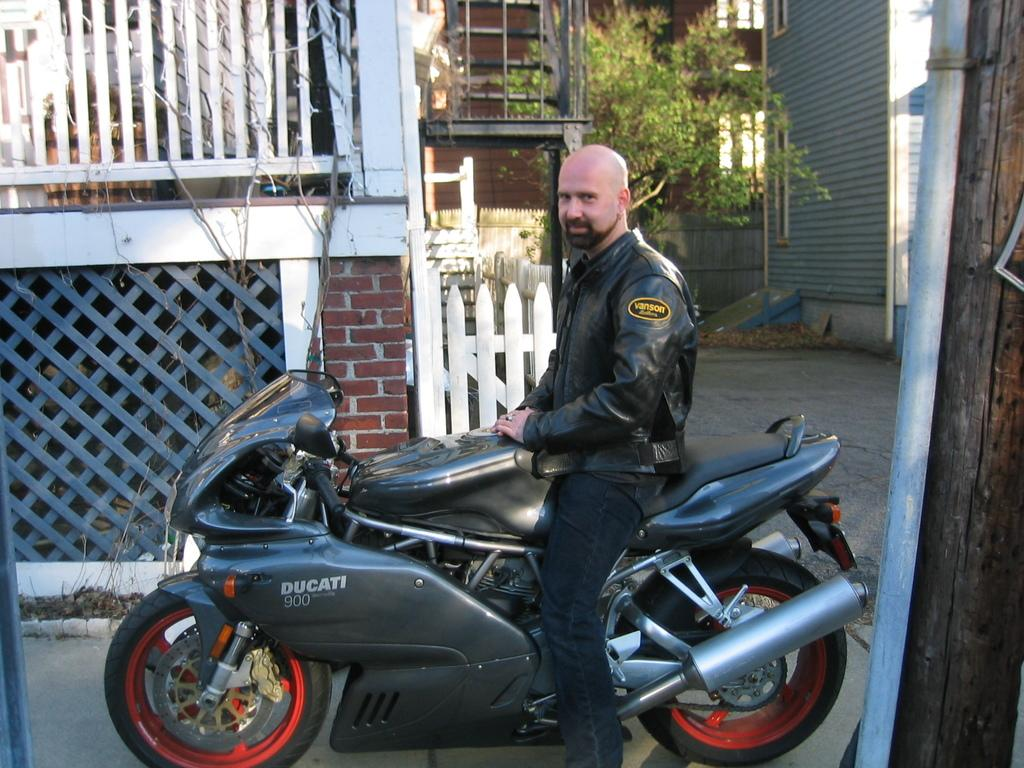Who is present in the image? There is a man in the image. What is the man doing in the image? The man is sitting on a motorcycle. What can be seen in the background of the image? There is a building and a plant in the background of the image. What type of stick can be seen in the man's hand in the image? There is no stick present in the man's hand or in the image. 